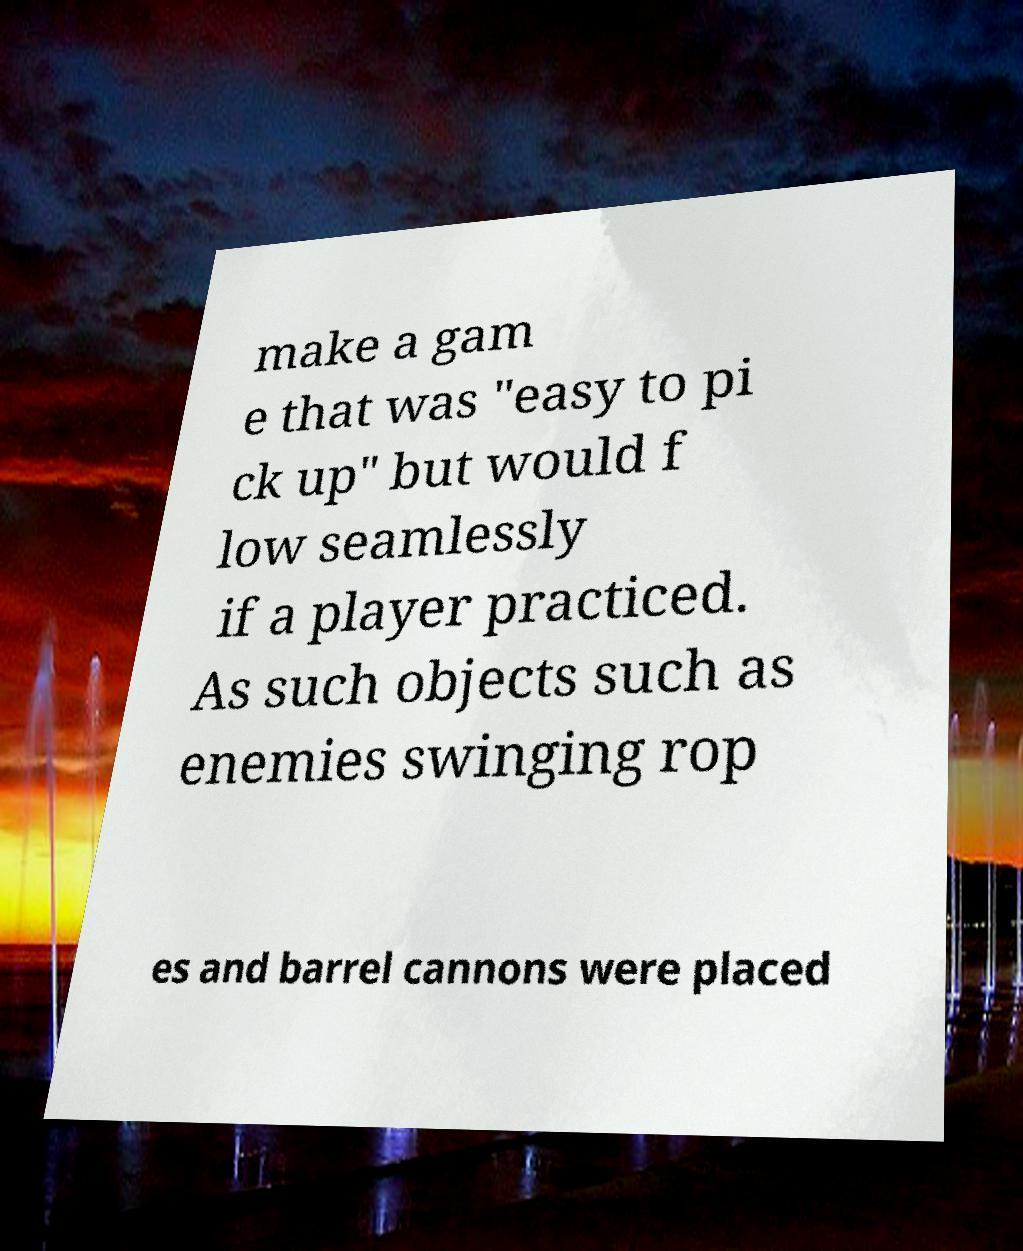Could you assist in decoding the text presented in this image and type it out clearly? make a gam e that was "easy to pi ck up" but would f low seamlessly if a player practiced. As such objects such as enemies swinging rop es and barrel cannons were placed 